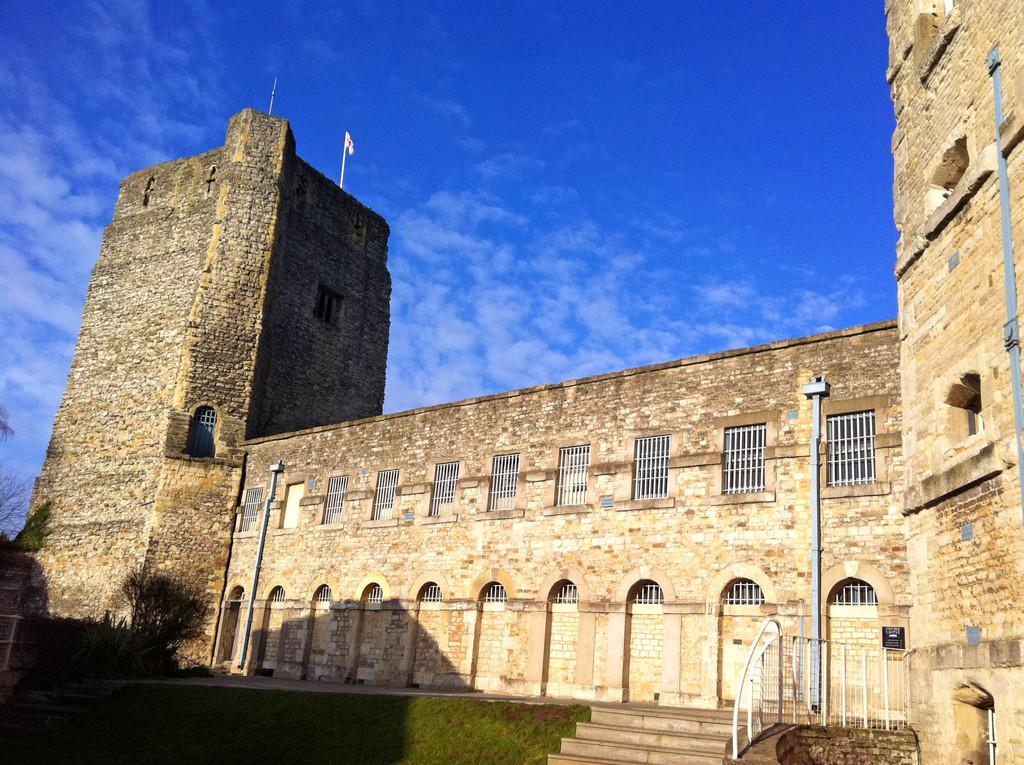What type of structure is present in the image? There is a building in the image. What features can be observed on the building? The building has windows and steps. What other objects or elements are present in the image? There is a fence, trees, a flag, and grass in the image. Additionally, the sky is visible in the background of the image, which contains clouds. What type of throne can be seen in the image? There is no throne present in the image. How does the judge feel about the situation in the image? There is no judge or situation depicted in the image, so it is not possible to determine the judge's feelings. 